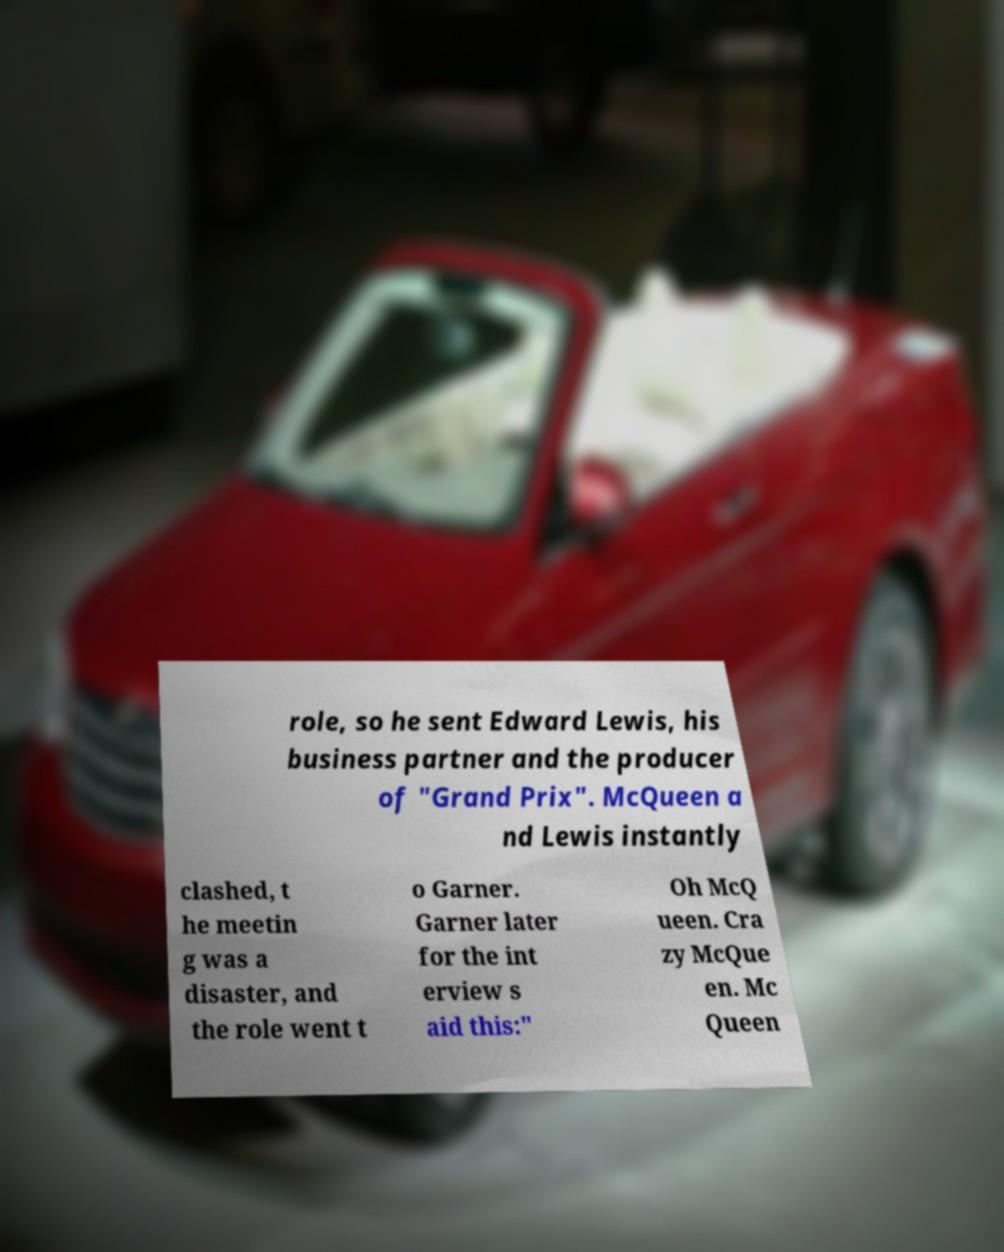Can you read and provide the text displayed in the image?This photo seems to have some interesting text. Can you extract and type it out for me? role, so he sent Edward Lewis, his business partner and the producer of "Grand Prix". McQueen a nd Lewis instantly clashed, t he meetin g was a disaster, and the role went t o Garner. Garner later for the int erview s aid this:" Oh McQ ueen. Cra zy McQue en. Mc Queen 